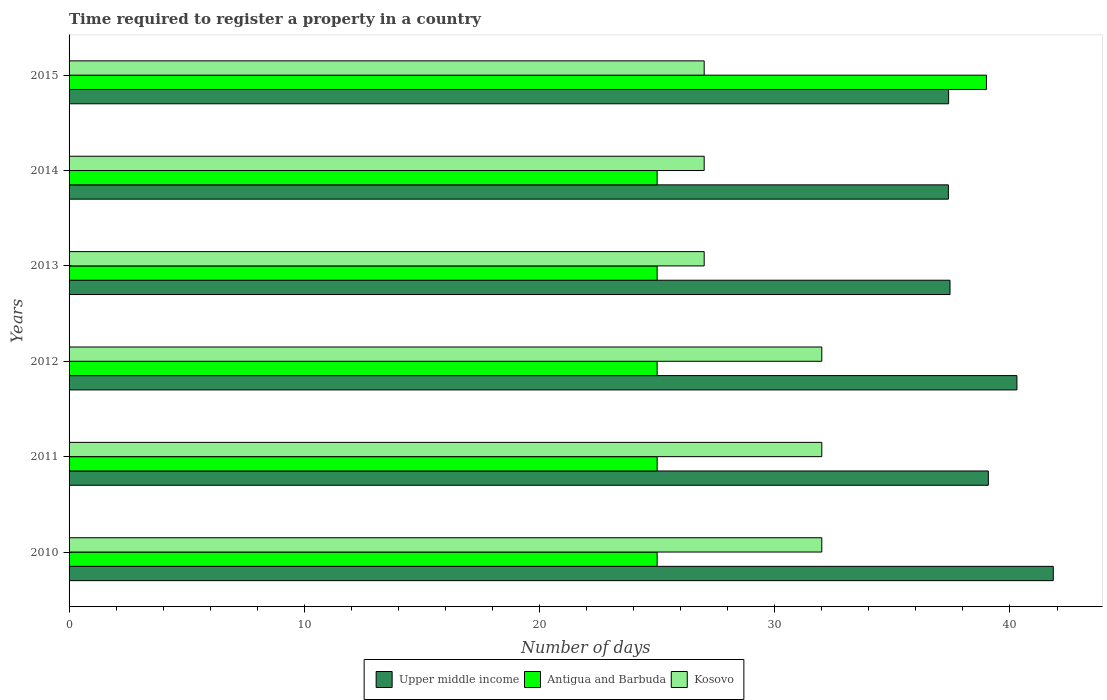How many different coloured bars are there?
Your answer should be very brief. 3. Are the number of bars per tick equal to the number of legend labels?
Ensure brevity in your answer.  Yes. What is the label of the 4th group of bars from the top?
Ensure brevity in your answer.  2012. In how many cases, is the number of bars for a given year not equal to the number of legend labels?
Provide a succinct answer. 0. Across all years, what is the minimum number of days required to register a property in Antigua and Barbuda?
Make the answer very short. 25. What is the total number of days required to register a property in Kosovo in the graph?
Offer a very short reply. 177. What is the difference between the number of days required to register a property in Upper middle income in 2011 and the number of days required to register a property in Kosovo in 2015?
Make the answer very short. 12.08. What is the average number of days required to register a property in Upper middle income per year?
Your response must be concise. 38.91. In the year 2013, what is the difference between the number of days required to register a property in Kosovo and number of days required to register a property in Upper middle income?
Offer a terse response. -10.45. What is the ratio of the number of days required to register a property in Upper middle income in 2010 to that in 2014?
Keep it short and to the point. 1.12. Is the number of days required to register a property in Antigua and Barbuda in 2014 less than that in 2015?
Give a very brief answer. Yes. What is the difference between the highest and the lowest number of days required to register a property in Kosovo?
Your answer should be very brief. 5. In how many years, is the number of days required to register a property in Kosovo greater than the average number of days required to register a property in Kosovo taken over all years?
Your response must be concise. 3. Is the sum of the number of days required to register a property in Upper middle income in 2010 and 2015 greater than the maximum number of days required to register a property in Antigua and Barbuda across all years?
Give a very brief answer. Yes. What does the 3rd bar from the top in 2013 represents?
Your answer should be very brief. Upper middle income. What does the 1st bar from the bottom in 2011 represents?
Offer a terse response. Upper middle income. Is it the case that in every year, the sum of the number of days required to register a property in Antigua and Barbuda and number of days required to register a property in Upper middle income is greater than the number of days required to register a property in Kosovo?
Keep it short and to the point. Yes. How many bars are there?
Your answer should be very brief. 18. Are all the bars in the graph horizontal?
Make the answer very short. Yes. How many years are there in the graph?
Your answer should be compact. 6. Does the graph contain any zero values?
Give a very brief answer. No. Where does the legend appear in the graph?
Your answer should be very brief. Bottom center. What is the title of the graph?
Ensure brevity in your answer.  Time required to register a property in a country. What is the label or title of the X-axis?
Make the answer very short. Number of days. What is the Number of days of Upper middle income in 2010?
Your response must be concise. 41.84. What is the Number of days of Antigua and Barbuda in 2010?
Offer a very short reply. 25. What is the Number of days of Upper middle income in 2011?
Provide a succinct answer. 39.08. What is the Number of days in Kosovo in 2011?
Provide a short and direct response. 32. What is the Number of days of Upper middle income in 2012?
Make the answer very short. 40.3. What is the Number of days in Antigua and Barbuda in 2012?
Provide a short and direct response. 25. What is the Number of days in Upper middle income in 2013?
Provide a short and direct response. 37.45. What is the Number of days of Kosovo in 2013?
Make the answer very short. 27. What is the Number of days of Upper middle income in 2014?
Provide a succinct answer. 37.38. What is the Number of days in Upper middle income in 2015?
Your answer should be very brief. 37.39. Across all years, what is the maximum Number of days of Upper middle income?
Your response must be concise. 41.84. Across all years, what is the maximum Number of days in Antigua and Barbuda?
Your response must be concise. 39. Across all years, what is the minimum Number of days of Upper middle income?
Offer a terse response. 37.38. Across all years, what is the minimum Number of days in Antigua and Barbuda?
Give a very brief answer. 25. Across all years, what is the minimum Number of days in Kosovo?
Provide a succinct answer. 27. What is the total Number of days of Upper middle income in the graph?
Offer a terse response. 233.44. What is the total Number of days of Antigua and Barbuda in the graph?
Provide a succinct answer. 164. What is the total Number of days in Kosovo in the graph?
Your answer should be very brief. 177. What is the difference between the Number of days of Upper middle income in 2010 and that in 2011?
Provide a succinct answer. 2.76. What is the difference between the Number of days in Kosovo in 2010 and that in 2011?
Give a very brief answer. 0. What is the difference between the Number of days of Upper middle income in 2010 and that in 2012?
Your answer should be very brief. 1.55. What is the difference between the Number of days of Kosovo in 2010 and that in 2012?
Offer a very short reply. 0. What is the difference between the Number of days in Upper middle income in 2010 and that in 2013?
Your answer should be compact. 4.39. What is the difference between the Number of days of Antigua and Barbuda in 2010 and that in 2013?
Provide a succinct answer. 0. What is the difference between the Number of days in Kosovo in 2010 and that in 2013?
Make the answer very short. 5. What is the difference between the Number of days in Upper middle income in 2010 and that in 2014?
Give a very brief answer. 4.46. What is the difference between the Number of days in Antigua and Barbuda in 2010 and that in 2014?
Offer a terse response. 0. What is the difference between the Number of days of Upper middle income in 2010 and that in 2015?
Provide a short and direct response. 4.45. What is the difference between the Number of days in Kosovo in 2010 and that in 2015?
Your answer should be compact. 5. What is the difference between the Number of days in Upper middle income in 2011 and that in 2012?
Offer a very short reply. -1.22. What is the difference between the Number of days of Antigua and Barbuda in 2011 and that in 2012?
Make the answer very short. 0. What is the difference between the Number of days of Upper middle income in 2011 and that in 2013?
Offer a terse response. 1.63. What is the difference between the Number of days in Kosovo in 2011 and that in 2013?
Offer a terse response. 5. What is the difference between the Number of days of Upper middle income in 2011 and that in 2014?
Your response must be concise. 1.7. What is the difference between the Number of days in Upper middle income in 2011 and that in 2015?
Your answer should be very brief. 1.69. What is the difference between the Number of days in Antigua and Barbuda in 2011 and that in 2015?
Your answer should be very brief. -14. What is the difference between the Number of days in Upper middle income in 2012 and that in 2013?
Your response must be concise. 2.84. What is the difference between the Number of days of Antigua and Barbuda in 2012 and that in 2013?
Keep it short and to the point. 0. What is the difference between the Number of days of Kosovo in 2012 and that in 2013?
Provide a succinct answer. 5. What is the difference between the Number of days in Upper middle income in 2012 and that in 2014?
Offer a very short reply. 2.91. What is the difference between the Number of days in Kosovo in 2012 and that in 2014?
Provide a succinct answer. 5. What is the difference between the Number of days in Upper middle income in 2012 and that in 2015?
Make the answer very short. 2.9. What is the difference between the Number of days in Upper middle income in 2013 and that in 2014?
Provide a short and direct response. 0.07. What is the difference between the Number of days in Kosovo in 2013 and that in 2014?
Provide a short and direct response. 0. What is the difference between the Number of days of Upper middle income in 2013 and that in 2015?
Make the answer very short. 0.06. What is the difference between the Number of days of Upper middle income in 2014 and that in 2015?
Make the answer very short. -0.01. What is the difference between the Number of days of Upper middle income in 2010 and the Number of days of Antigua and Barbuda in 2011?
Your answer should be very brief. 16.84. What is the difference between the Number of days in Upper middle income in 2010 and the Number of days in Kosovo in 2011?
Your response must be concise. 9.84. What is the difference between the Number of days of Antigua and Barbuda in 2010 and the Number of days of Kosovo in 2011?
Offer a very short reply. -7. What is the difference between the Number of days in Upper middle income in 2010 and the Number of days in Antigua and Barbuda in 2012?
Keep it short and to the point. 16.84. What is the difference between the Number of days in Upper middle income in 2010 and the Number of days in Kosovo in 2012?
Give a very brief answer. 9.84. What is the difference between the Number of days in Upper middle income in 2010 and the Number of days in Antigua and Barbuda in 2013?
Provide a short and direct response. 16.84. What is the difference between the Number of days of Upper middle income in 2010 and the Number of days of Kosovo in 2013?
Ensure brevity in your answer.  14.84. What is the difference between the Number of days of Antigua and Barbuda in 2010 and the Number of days of Kosovo in 2013?
Keep it short and to the point. -2. What is the difference between the Number of days of Upper middle income in 2010 and the Number of days of Antigua and Barbuda in 2014?
Offer a terse response. 16.84. What is the difference between the Number of days in Upper middle income in 2010 and the Number of days in Kosovo in 2014?
Offer a very short reply. 14.84. What is the difference between the Number of days in Upper middle income in 2010 and the Number of days in Antigua and Barbuda in 2015?
Your response must be concise. 2.84. What is the difference between the Number of days of Upper middle income in 2010 and the Number of days of Kosovo in 2015?
Your answer should be very brief. 14.84. What is the difference between the Number of days in Antigua and Barbuda in 2010 and the Number of days in Kosovo in 2015?
Your answer should be very brief. -2. What is the difference between the Number of days of Upper middle income in 2011 and the Number of days of Antigua and Barbuda in 2012?
Ensure brevity in your answer.  14.08. What is the difference between the Number of days of Upper middle income in 2011 and the Number of days of Kosovo in 2012?
Keep it short and to the point. 7.08. What is the difference between the Number of days of Antigua and Barbuda in 2011 and the Number of days of Kosovo in 2012?
Your answer should be compact. -7. What is the difference between the Number of days in Upper middle income in 2011 and the Number of days in Antigua and Barbuda in 2013?
Make the answer very short. 14.08. What is the difference between the Number of days in Upper middle income in 2011 and the Number of days in Kosovo in 2013?
Offer a very short reply. 12.08. What is the difference between the Number of days of Upper middle income in 2011 and the Number of days of Antigua and Barbuda in 2014?
Keep it short and to the point. 14.08. What is the difference between the Number of days of Upper middle income in 2011 and the Number of days of Kosovo in 2014?
Your answer should be compact. 12.08. What is the difference between the Number of days in Antigua and Barbuda in 2011 and the Number of days in Kosovo in 2014?
Offer a terse response. -2. What is the difference between the Number of days in Upper middle income in 2011 and the Number of days in Antigua and Barbuda in 2015?
Offer a terse response. 0.08. What is the difference between the Number of days of Upper middle income in 2011 and the Number of days of Kosovo in 2015?
Offer a terse response. 12.08. What is the difference between the Number of days in Upper middle income in 2012 and the Number of days in Antigua and Barbuda in 2013?
Provide a short and direct response. 15.3. What is the difference between the Number of days in Upper middle income in 2012 and the Number of days in Kosovo in 2013?
Make the answer very short. 13.3. What is the difference between the Number of days of Upper middle income in 2012 and the Number of days of Antigua and Barbuda in 2014?
Offer a very short reply. 15.3. What is the difference between the Number of days in Upper middle income in 2012 and the Number of days in Kosovo in 2014?
Provide a succinct answer. 13.3. What is the difference between the Number of days of Upper middle income in 2012 and the Number of days of Antigua and Barbuda in 2015?
Provide a short and direct response. 1.3. What is the difference between the Number of days in Upper middle income in 2012 and the Number of days in Kosovo in 2015?
Provide a short and direct response. 13.3. What is the difference between the Number of days in Antigua and Barbuda in 2012 and the Number of days in Kosovo in 2015?
Offer a terse response. -2. What is the difference between the Number of days of Upper middle income in 2013 and the Number of days of Antigua and Barbuda in 2014?
Keep it short and to the point. 12.45. What is the difference between the Number of days in Upper middle income in 2013 and the Number of days in Kosovo in 2014?
Your response must be concise. 10.45. What is the difference between the Number of days in Upper middle income in 2013 and the Number of days in Antigua and Barbuda in 2015?
Provide a succinct answer. -1.55. What is the difference between the Number of days of Upper middle income in 2013 and the Number of days of Kosovo in 2015?
Provide a short and direct response. 10.45. What is the difference between the Number of days in Upper middle income in 2014 and the Number of days in Antigua and Barbuda in 2015?
Keep it short and to the point. -1.62. What is the difference between the Number of days in Upper middle income in 2014 and the Number of days in Kosovo in 2015?
Your response must be concise. 10.38. What is the average Number of days of Upper middle income per year?
Offer a very short reply. 38.91. What is the average Number of days of Antigua and Barbuda per year?
Your response must be concise. 27.33. What is the average Number of days in Kosovo per year?
Your answer should be compact. 29.5. In the year 2010, what is the difference between the Number of days of Upper middle income and Number of days of Antigua and Barbuda?
Ensure brevity in your answer.  16.84. In the year 2010, what is the difference between the Number of days in Upper middle income and Number of days in Kosovo?
Keep it short and to the point. 9.84. In the year 2010, what is the difference between the Number of days of Antigua and Barbuda and Number of days of Kosovo?
Ensure brevity in your answer.  -7. In the year 2011, what is the difference between the Number of days in Upper middle income and Number of days in Antigua and Barbuda?
Ensure brevity in your answer.  14.08. In the year 2011, what is the difference between the Number of days in Upper middle income and Number of days in Kosovo?
Your answer should be compact. 7.08. In the year 2012, what is the difference between the Number of days of Upper middle income and Number of days of Antigua and Barbuda?
Offer a very short reply. 15.3. In the year 2012, what is the difference between the Number of days of Upper middle income and Number of days of Kosovo?
Provide a succinct answer. 8.3. In the year 2013, what is the difference between the Number of days of Upper middle income and Number of days of Antigua and Barbuda?
Keep it short and to the point. 12.45. In the year 2013, what is the difference between the Number of days of Upper middle income and Number of days of Kosovo?
Give a very brief answer. 10.45. In the year 2013, what is the difference between the Number of days in Antigua and Barbuda and Number of days in Kosovo?
Your answer should be compact. -2. In the year 2014, what is the difference between the Number of days in Upper middle income and Number of days in Antigua and Barbuda?
Give a very brief answer. 12.38. In the year 2014, what is the difference between the Number of days of Upper middle income and Number of days of Kosovo?
Provide a succinct answer. 10.38. In the year 2015, what is the difference between the Number of days of Upper middle income and Number of days of Antigua and Barbuda?
Ensure brevity in your answer.  -1.61. In the year 2015, what is the difference between the Number of days of Upper middle income and Number of days of Kosovo?
Your answer should be compact. 10.39. What is the ratio of the Number of days of Upper middle income in 2010 to that in 2011?
Ensure brevity in your answer.  1.07. What is the ratio of the Number of days of Kosovo in 2010 to that in 2011?
Give a very brief answer. 1. What is the ratio of the Number of days in Upper middle income in 2010 to that in 2012?
Offer a very short reply. 1.04. What is the ratio of the Number of days of Upper middle income in 2010 to that in 2013?
Your answer should be compact. 1.12. What is the ratio of the Number of days of Kosovo in 2010 to that in 2013?
Your answer should be very brief. 1.19. What is the ratio of the Number of days in Upper middle income in 2010 to that in 2014?
Provide a succinct answer. 1.12. What is the ratio of the Number of days of Kosovo in 2010 to that in 2014?
Offer a very short reply. 1.19. What is the ratio of the Number of days of Upper middle income in 2010 to that in 2015?
Your answer should be compact. 1.12. What is the ratio of the Number of days in Antigua and Barbuda in 2010 to that in 2015?
Ensure brevity in your answer.  0.64. What is the ratio of the Number of days of Kosovo in 2010 to that in 2015?
Your answer should be very brief. 1.19. What is the ratio of the Number of days of Upper middle income in 2011 to that in 2012?
Offer a terse response. 0.97. What is the ratio of the Number of days of Antigua and Barbuda in 2011 to that in 2012?
Your answer should be very brief. 1. What is the ratio of the Number of days of Upper middle income in 2011 to that in 2013?
Provide a short and direct response. 1.04. What is the ratio of the Number of days of Antigua and Barbuda in 2011 to that in 2013?
Make the answer very short. 1. What is the ratio of the Number of days of Kosovo in 2011 to that in 2013?
Offer a very short reply. 1.19. What is the ratio of the Number of days of Upper middle income in 2011 to that in 2014?
Offer a terse response. 1.05. What is the ratio of the Number of days of Kosovo in 2011 to that in 2014?
Your answer should be very brief. 1.19. What is the ratio of the Number of days in Upper middle income in 2011 to that in 2015?
Your answer should be compact. 1.05. What is the ratio of the Number of days of Antigua and Barbuda in 2011 to that in 2015?
Offer a very short reply. 0.64. What is the ratio of the Number of days of Kosovo in 2011 to that in 2015?
Your response must be concise. 1.19. What is the ratio of the Number of days in Upper middle income in 2012 to that in 2013?
Ensure brevity in your answer.  1.08. What is the ratio of the Number of days in Antigua and Barbuda in 2012 to that in 2013?
Keep it short and to the point. 1. What is the ratio of the Number of days in Kosovo in 2012 to that in 2013?
Make the answer very short. 1.19. What is the ratio of the Number of days of Upper middle income in 2012 to that in 2014?
Your answer should be very brief. 1.08. What is the ratio of the Number of days of Antigua and Barbuda in 2012 to that in 2014?
Give a very brief answer. 1. What is the ratio of the Number of days in Kosovo in 2012 to that in 2014?
Your answer should be very brief. 1.19. What is the ratio of the Number of days of Upper middle income in 2012 to that in 2015?
Give a very brief answer. 1.08. What is the ratio of the Number of days of Antigua and Barbuda in 2012 to that in 2015?
Provide a short and direct response. 0.64. What is the ratio of the Number of days of Kosovo in 2012 to that in 2015?
Your answer should be very brief. 1.19. What is the ratio of the Number of days of Antigua and Barbuda in 2013 to that in 2014?
Make the answer very short. 1. What is the ratio of the Number of days of Kosovo in 2013 to that in 2014?
Provide a succinct answer. 1. What is the ratio of the Number of days in Antigua and Barbuda in 2013 to that in 2015?
Make the answer very short. 0.64. What is the ratio of the Number of days of Kosovo in 2013 to that in 2015?
Your response must be concise. 1. What is the ratio of the Number of days of Antigua and Barbuda in 2014 to that in 2015?
Give a very brief answer. 0.64. What is the difference between the highest and the second highest Number of days of Upper middle income?
Keep it short and to the point. 1.55. What is the difference between the highest and the second highest Number of days of Antigua and Barbuda?
Your answer should be very brief. 14. What is the difference between the highest and the second highest Number of days in Kosovo?
Provide a short and direct response. 0. What is the difference between the highest and the lowest Number of days of Upper middle income?
Make the answer very short. 4.46. What is the difference between the highest and the lowest Number of days of Kosovo?
Your answer should be very brief. 5. 